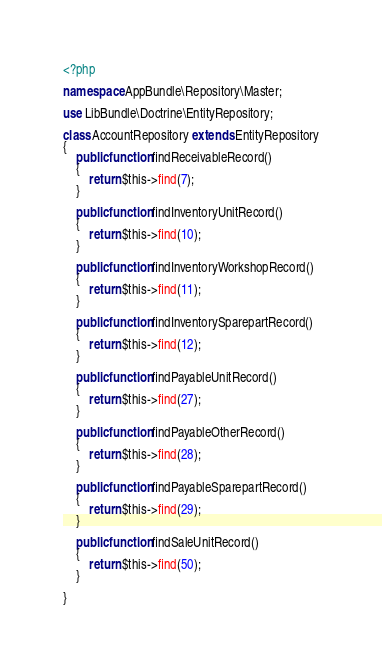<code> <loc_0><loc_0><loc_500><loc_500><_PHP_><?php

namespace AppBundle\Repository\Master;

use LibBundle\Doctrine\EntityRepository;

class AccountRepository extends EntityRepository
{
    public function findReceivableRecord()
    {
        return $this->find(7);
    }
    
    public function findInventoryUnitRecord()
    {
        return $this->find(10);
    }
    
    public function findInventoryWorkshopRecord()
    {
        return $this->find(11);
    }
    
    public function findInventorySparepartRecord()
    {
        return $this->find(12);
    }
    
    public function findPayableUnitRecord()
    {
        return $this->find(27);
    }
    
    public function findPayableOtherRecord()
    {
        return $this->find(28);
    }
    
    public function findPayableSparepartRecord()
    {
        return $this->find(29);
    }
    
    public function findSaleUnitRecord()
    {
        return $this->find(50);
    }
    
}</code> 